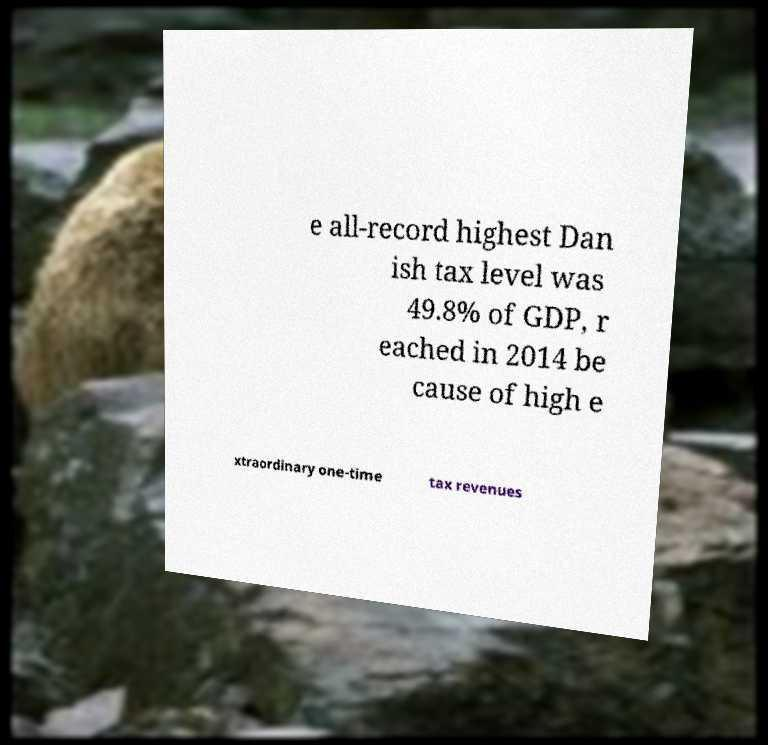Please read and relay the text visible in this image. What does it say? e all-record highest Dan ish tax level was 49.8% of GDP, r eached in 2014 be cause of high e xtraordinary one-time tax revenues 